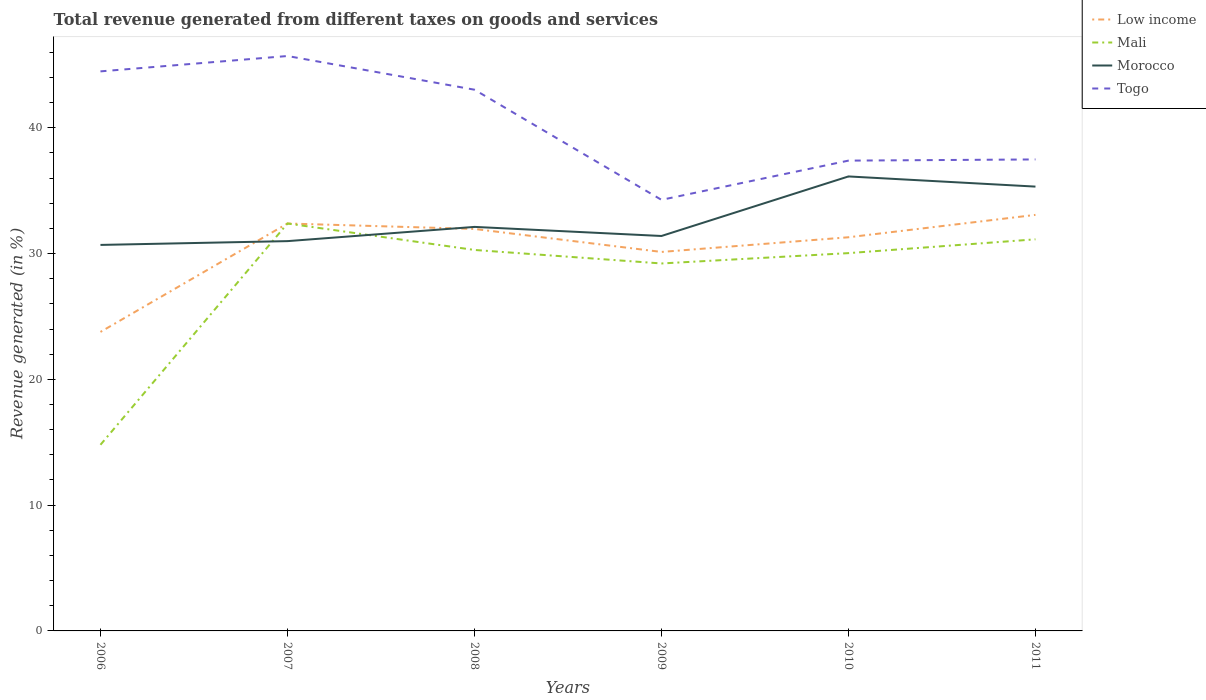Does the line corresponding to Mali intersect with the line corresponding to Morocco?
Keep it short and to the point. Yes. Across all years, what is the maximum total revenue generated in Low income?
Your answer should be compact. 23.77. In which year was the total revenue generated in Morocco maximum?
Keep it short and to the point. 2006. What is the total total revenue generated in Togo in the graph?
Your response must be concise. 10.21. What is the difference between the highest and the second highest total revenue generated in Low income?
Offer a very short reply. 9.31. Are the values on the major ticks of Y-axis written in scientific E-notation?
Your answer should be very brief. No. Does the graph contain grids?
Your answer should be compact. No. How are the legend labels stacked?
Provide a succinct answer. Vertical. What is the title of the graph?
Offer a very short reply. Total revenue generated from different taxes on goods and services. What is the label or title of the X-axis?
Offer a terse response. Years. What is the label or title of the Y-axis?
Your answer should be very brief. Revenue generated (in %). What is the Revenue generated (in %) of Low income in 2006?
Keep it short and to the point. 23.77. What is the Revenue generated (in %) in Mali in 2006?
Ensure brevity in your answer.  14.8. What is the Revenue generated (in %) in Morocco in 2006?
Keep it short and to the point. 30.69. What is the Revenue generated (in %) in Togo in 2006?
Offer a terse response. 44.49. What is the Revenue generated (in %) in Low income in 2007?
Give a very brief answer. 32.39. What is the Revenue generated (in %) of Mali in 2007?
Provide a short and direct response. 32.39. What is the Revenue generated (in %) in Morocco in 2007?
Your answer should be compact. 30.99. What is the Revenue generated (in %) in Togo in 2007?
Offer a terse response. 45.71. What is the Revenue generated (in %) in Low income in 2008?
Your answer should be very brief. 31.96. What is the Revenue generated (in %) of Mali in 2008?
Ensure brevity in your answer.  30.29. What is the Revenue generated (in %) of Morocco in 2008?
Give a very brief answer. 32.12. What is the Revenue generated (in %) in Togo in 2008?
Make the answer very short. 43.03. What is the Revenue generated (in %) of Low income in 2009?
Keep it short and to the point. 30.13. What is the Revenue generated (in %) in Mali in 2009?
Your answer should be compact. 29.21. What is the Revenue generated (in %) of Morocco in 2009?
Your answer should be very brief. 31.4. What is the Revenue generated (in %) of Togo in 2009?
Give a very brief answer. 34.27. What is the Revenue generated (in %) of Low income in 2010?
Give a very brief answer. 31.3. What is the Revenue generated (in %) in Mali in 2010?
Your response must be concise. 30.04. What is the Revenue generated (in %) of Morocco in 2010?
Your answer should be compact. 36.13. What is the Revenue generated (in %) of Togo in 2010?
Your response must be concise. 37.39. What is the Revenue generated (in %) in Low income in 2011?
Offer a terse response. 33.08. What is the Revenue generated (in %) of Mali in 2011?
Provide a short and direct response. 31.13. What is the Revenue generated (in %) in Morocco in 2011?
Your response must be concise. 35.33. What is the Revenue generated (in %) in Togo in 2011?
Your answer should be very brief. 37.48. Across all years, what is the maximum Revenue generated (in %) of Low income?
Give a very brief answer. 33.08. Across all years, what is the maximum Revenue generated (in %) of Mali?
Your answer should be compact. 32.39. Across all years, what is the maximum Revenue generated (in %) in Morocco?
Your answer should be very brief. 36.13. Across all years, what is the maximum Revenue generated (in %) of Togo?
Your response must be concise. 45.71. Across all years, what is the minimum Revenue generated (in %) of Low income?
Your answer should be compact. 23.77. Across all years, what is the minimum Revenue generated (in %) in Mali?
Provide a succinct answer. 14.8. Across all years, what is the minimum Revenue generated (in %) in Morocco?
Offer a terse response. 30.69. Across all years, what is the minimum Revenue generated (in %) of Togo?
Ensure brevity in your answer.  34.27. What is the total Revenue generated (in %) in Low income in the graph?
Ensure brevity in your answer.  182.63. What is the total Revenue generated (in %) in Mali in the graph?
Make the answer very short. 167.86. What is the total Revenue generated (in %) in Morocco in the graph?
Your response must be concise. 196.66. What is the total Revenue generated (in %) of Togo in the graph?
Your response must be concise. 242.37. What is the difference between the Revenue generated (in %) in Low income in 2006 and that in 2007?
Your response must be concise. -8.62. What is the difference between the Revenue generated (in %) in Mali in 2006 and that in 2007?
Ensure brevity in your answer.  -17.59. What is the difference between the Revenue generated (in %) of Morocco in 2006 and that in 2007?
Keep it short and to the point. -0.3. What is the difference between the Revenue generated (in %) in Togo in 2006 and that in 2007?
Give a very brief answer. -1.22. What is the difference between the Revenue generated (in %) of Low income in 2006 and that in 2008?
Your response must be concise. -8.19. What is the difference between the Revenue generated (in %) in Mali in 2006 and that in 2008?
Provide a short and direct response. -15.49. What is the difference between the Revenue generated (in %) of Morocco in 2006 and that in 2008?
Provide a short and direct response. -1.43. What is the difference between the Revenue generated (in %) in Togo in 2006 and that in 2008?
Provide a succinct answer. 1.46. What is the difference between the Revenue generated (in %) of Low income in 2006 and that in 2009?
Keep it short and to the point. -6.36. What is the difference between the Revenue generated (in %) in Mali in 2006 and that in 2009?
Your answer should be very brief. -14.42. What is the difference between the Revenue generated (in %) in Morocco in 2006 and that in 2009?
Your answer should be compact. -0.71. What is the difference between the Revenue generated (in %) of Togo in 2006 and that in 2009?
Your answer should be compact. 10.21. What is the difference between the Revenue generated (in %) in Low income in 2006 and that in 2010?
Your answer should be very brief. -7.53. What is the difference between the Revenue generated (in %) of Mali in 2006 and that in 2010?
Give a very brief answer. -15.24. What is the difference between the Revenue generated (in %) in Morocco in 2006 and that in 2010?
Make the answer very short. -5.44. What is the difference between the Revenue generated (in %) in Togo in 2006 and that in 2010?
Give a very brief answer. 7.1. What is the difference between the Revenue generated (in %) of Low income in 2006 and that in 2011?
Make the answer very short. -9.31. What is the difference between the Revenue generated (in %) of Mali in 2006 and that in 2011?
Your answer should be very brief. -16.34. What is the difference between the Revenue generated (in %) in Morocco in 2006 and that in 2011?
Your response must be concise. -4.64. What is the difference between the Revenue generated (in %) of Togo in 2006 and that in 2011?
Provide a short and direct response. 7. What is the difference between the Revenue generated (in %) in Low income in 2007 and that in 2008?
Keep it short and to the point. 0.43. What is the difference between the Revenue generated (in %) in Mali in 2007 and that in 2008?
Make the answer very short. 2.1. What is the difference between the Revenue generated (in %) of Morocco in 2007 and that in 2008?
Give a very brief answer. -1.13. What is the difference between the Revenue generated (in %) of Togo in 2007 and that in 2008?
Your answer should be compact. 2.68. What is the difference between the Revenue generated (in %) in Low income in 2007 and that in 2009?
Your answer should be compact. 2.26. What is the difference between the Revenue generated (in %) of Mali in 2007 and that in 2009?
Ensure brevity in your answer.  3.18. What is the difference between the Revenue generated (in %) in Morocco in 2007 and that in 2009?
Ensure brevity in your answer.  -0.41. What is the difference between the Revenue generated (in %) in Togo in 2007 and that in 2009?
Your answer should be very brief. 11.44. What is the difference between the Revenue generated (in %) of Low income in 2007 and that in 2010?
Your response must be concise. 1.09. What is the difference between the Revenue generated (in %) in Mali in 2007 and that in 2010?
Provide a succinct answer. 2.35. What is the difference between the Revenue generated (in %) in Morocco in 2007 and that in 2010?
Your answer should be very brief. -5.14. What is the difference between the Revenue generated (in %) in Togo in 2007 and that in 2010?
Offer a very short reply. 8.32. What is the difference between the Revenue generated (in %) in Low income in 2007 and that in 2011?
Offer a terse response. -0.69. What is the difference between the Revenue generated (in %) in Mali in 2007 and that in 2011?
Make the answer very short. 1.26. What is the difference between the Revenue generated (in %) in Morocco in 2007 and that in 2011?
Your answer should be compact. -4.34. What is the difference between the Revenue generated (in %) in Togo in 2007 and that in 2011?
Ensure brevity in your answer.  8.22. What is the difference between the Revenue generated (in %) in Low income in 2008 and that in 2009?
Offer a very short reply. 1.83. What is the difference between the Revenue generated (in %) of Mali in 2008 and that in 2009?
Give a very brief answer. 1.07. What is the difference between the Revenue generated (in %) of Morocco in 2008 and that in 2009?
Give a very brief answer. 0.72. What is the difference between the Revenue generated (in %) of Togo in 2008 and that in 2009?
Your response must be concise. 8.76. What is the difference between the Revenue generated (in %) in Low income in 2008 and that in 2010?
Ensure brevity in your answer.  0.66. What is the difference between the Revenue generated (in %) of Mali in 2008 and that in 2010?
Your answer should be compact. 0.25. What is the difference between the Revenue generated (in %) of Morocco in 2008 and that in 2010?
Offer a very short reply. -4.01. What is the difference between the Revenue generated (in %) in Togo in 2008 and that in 2010?
Provide a short and direct response. 5.64. What is the difference between the Revenue generated (in %) in Low income in 2008 and that in 2011?
Make the answer very short. -1.12. What is the difference between the Revenue generated (in %) in Mali in 2008 and that in 2011?
Keep it short and to the point. -0.85. What is the difference between the Revenue generated (in %) in Morocco in 2008 and that in 2011?
Your answer should be compact. -3.2. What is the difference between the Revenue generated (in %) in Togo in 2008 and that in 2011?
Keep it short and to the point. 5.54. What is the difference between the Revenue generated (in %) in Low income in 2009 and that in 2010?
Your answer should be very brief. -1.17. What is the difference between the Revenue generated (in %) in Mali in 2009 and that in 2010?
Ensure brevity in your answer.  -0.82. What is the difference between the Revenue generated (in %) in Morocco in 2009 and that in 2010?
Your response must be concise. -4.73. What is the difference between the Revenue generated (in %) in Togo in 2009 and that in 2010?
Offer a very short reply. -3.12. What is the difference between the Revenue generated (in %) of Low income in 2009 and that in 2011?
Ensure brevity in your answer.  -2.95. What is the difference between the Revenue generated (in %) of Mali in 2009 and that in 2011?
Ensure brevity in your answer.  -1.92. What is the difference between the Revenue generated (in %) in Morocco in 2009 and that in 2011?
Offer a terse response. -3.93. What is the difference between the Revenue generated (in %) of Togo in 2009 and that in 2011?
Provide a succinct answer. -3.21. What is the difference between the Revenue generated (in %) of Low income in 2010 and that in 2011?
Keep it short and to the point. -1.78. What is the difference between the Revenue generated (in %) in Mali in 2010 and that in 2011?
Make the answer very short. -1.1. What is the difference between the Revenue generated (in %) of Morocco in 2010 and that in 2011?
Keep it short and to the point. 0.81. What is the difference between the Revenue generated (in %) of Togo in 2010 and that in 2011?
Provide a succinct answer. -0.09. What is the difference between the Revenue generated (in %) of Low income in 2006 and the Revenue generated (in %) of Mali in 2007?
Give a very brief answer. -8.62. What is the difference between the Revenue generated (in %) in Low income in 2006 and the Revenue generated (in %) in Morocco in 2007?
Make the answer very short. -7.22. What is the difference between the Revenue generated (in %) of Low income in 2006 and the Revenue generated (in %) of Togo in 2007?
Keep it short and to the point. -21.94. What is the difference between the Revenue generated (in %) in Mali in 2006 and the Revenue generated (in %) in Morocco in 2007?
Offer a terse response. -16.19. What is the difference between the Revenue generated (in %) in Mali in 2006 and the Revenue generated (in %) in Togo in 2007?
Your answer should be compact. -30.91. What is the difference between the Revenue generated (in %) in Morocco in 2006 and the Revenue generated (in %) in Togo in 2007?
Ensure brevity in your answer.  -15.02. What is the difference between the Revenue generated (in %) in Low income in 2006 and the Revenue generated (in %) in Mali in 2008?
Provide a succinct answer. -6.52. What is the difference between the Revenue generated (in %) of Low income in 2006 and the Revenue generated (in %) of Morocco in 2008?
Your answer should be compact. -8.35. What is the difference between the Revenue generated (in %) of Low income in 2006 and the Revenue generated (in %) of Togo in 2008?
Your answer should be very brief. -19.26. What is the difference between the Revenue generated (in %) of Mali in 2006 and the Revenue generated (in %) of Morocco in 2008?
Ensure brevity in your answer.  -17.32. What is the difference between the Revenue generated (in %) in Mali in 2006 and the Revenue generated (in %) in Togo in 2008?
Make the answer very short. -28.23. What is the difference between the Revenue generated (in %) in Morocco in 2006 and the Revenue generated (in %) in Togo in 2008?
Your answer should be compact. -12.34. What is the difference between the Revenue generated (in %) in Low income in 2006 and the Revenue generated (in %) in Mali in 2009?
Make the answer very short. -5.44. What is the difference between the Revenue generated (in %) in Low income in 2006 and the Revenue generated (in %) in Morocco in 2009?
Provide a succinct answer. -7.63. What is the difference between the Revenue generated (in %) in Low income in 2006 and the Revenue generated (in %) in Togo in 2009?
Provide a succinct answer. -10.5. What is the difference between the Revenue generated (in %) of Mali in 2006 and the Revenue generated (in %) of Morocco in 2009?
Keep it short and to the point. -16.6. What is the difference between the Revenue generated (in %) of Mali in 2006 and the Revenue generated (in %) of Togo in 2009?
Provide a short and direct response. -19.47. What is the difference between the Revenue generated (in %) of Morocco in 2006 and the Revenue generated (in %) of Togo in 2009?
Provide a succinct answer. -3.58. What is the difference between the Revenue generated (in %) in Low income in 2006 and the Revenue generated (in %) in Mali in 2010?
Provide a short and direct response. -6.27. What is the difference between the Revenue generated (in %) of Low income in 2006 and the Revenue generated (in %) of Morocco in 2010?
Your answer should be very brief. -12.36. What is the difference between the Revenue generated (in %) of Low income in 2006 and the Revenue generated (in %) of Togo in 2010?
Ensure brevity in your answer.  -13.62. What is the difference between the Revenue generated (in %) in Mali in 2006 and the Revenue generated (in %) in Morocco in 2010?
Offer a terse response. -21.33. What is the difference between the Revenue generated (in %) of Mali in 2006 and the Revenue generated (in %) of Togo in 2010?
Give a very brief answer. -22.59. What is the difference between the Revenue generated (in %) of Morocco in 2006 and the Revenue generated (in %) of Togo in 2010?
Your answer should be very brief. -6.7. What is the difference between the Revenue generated (in %) in Low income in 2006 and the Revenue generated (in %) in Mali in 2011?
Your response must be concise. -7.36. What is the difference between the Revenue generated (in %) in Low income in 2006 and the Revenue generated (in %) in Morocco in 2011?
Your answer should be compact. -11.55. What is the difference between the Revenue generated (in %) in Low income in 2006 and the Revenue generated (in %) in Togo in 2011?
Give a very brief answer. -13.71. What is the difference between the Revenue generated (in %) in Mali in 2006 and the Revenue generated (in %) in Morocco in 2011?
Your answer should be very brief. -20.53. What is the difference between the Revenue generated (in %) of Mali in 2006 and the Revenue generated (in %) of Togo in 2011?
Ensure brevity in your answer.  -22.69. What is the difference between the Revenue generated (in %) in Morocco in 2006 and the Revenue generated (in %) in Togo in 2011?
Your response must be concise. -6.8. What is the difference between the Revenue generated (in %) of Low income in 2007 and the Revenue generated (in %) of Mali in 2008?
Ensure brevity in your answer.  2.1. What is the difference between the Revenue generated (in %) in Low income in 2007 and the Revenue generated (in %) in Morocco in 2008?
Provide a short and direct response. 0.27. What is the difference between the Revenue generated (in %) in Low income in 2007 and the Revenue generated (in %) in Togo in 2008?
Keep it short and to the point. -10.64. What is the difference between the Revenue generated (in %) of Mali in 2007 and the Revenue generated (in %) of Morocco in 2008?
Ensure brevity in your answer.  0.27. What is the difference between the Revenue generated (in %) of Mali in 2007 and the Revenue generated (in %) of Togo in 2008?
Your response must be concise. -10.64. What is the difference between the Revenue generated (in %) in Morocco in 2007 and the Revenue generated (in %) in Togo in 2008?
Keep it short and to the point. -12.04. What is the difference between the Revenue generated (in %) of Low income in 2007 and the Revenue generated (in %) of Mali in 2009?
Your answer should be compact. 3.18. What is the difference between the Revenue generated (in %) in Low income in 2007 and the Revenue generated (in %) in Togo in 2009?
Provide a succinct answer. -1.88. What is the difference between the Revenue generated (in %) of Mali in 2007 and the Revenue generated (in %) of Morocco in 2009?
Keep it short and to the point. 0.99. What is the difference between the Revenue generated (in %) in Mali in 2007 and the Revenue generated (in %) in Togo in 2009?
Offer a terse response. -1.88. What is the difference between the Revenue generated (in %) of Morocco in 2007 and the Revenue generated (in %) of Togo in 2009?
Offer a very short reply. -3.28. What is the difference between the Revenue generated (in %) of Low income in 2007 and the Revenue generated (in %) of Mali in 2010?
Provide a succinct answer. 2.35. What is the difference between the Revenue generated (in %) of Low income in 2007 and the Revenue generated (in %) of Morocco in 2010?
Provide a short and direct response. -3.74. What is the difference between the Revenue generated (in %) in Low income in 2007 and the Revenue generated (in %) in Togo in 2010?
Your answer should be compact. -5. What is the difference between the Revenue generated (in %) of Mali in 2007 and the Revenue generated (in %) of Morocco in 2010?
Your answer should be compact. -3.74. What is the difference between the Revenue generated (in %) of Mali in 2007 and the Revenue generated (in %) of Togo in 2010?
Your answer should be very brief. -5. What is the difference between the Revenue generated (in %) of Morocco in 2007 and the Revenue generated (in %) of Togo in 2010?
Provide a succinct answer. -6.4. What is the difference between the Revenue generated (in %) in Low income in 2007 and the Revenue generated (in %) in Mali in 2011?
Make the answer very short. 1.26. What is the difference between the Revenue generated (in %) of Low income in 2007 and the Revenue generated (in %) of Morocco in 2011?
Offer a very short reply. -2.93. What is the difference between the Revenue generated (in %) of Low income in 2007 and the Revenue generated (in %) of Togo in 2011?
Give a very brief answer. -5.09. What is the difference between the Revenue generated (in %) of Mali in 2007 and the Revenue generated (in %) of Morocco in 2011?
Ensure brevity in your answer.  -2.93. What is the difference between the Revenue generated (in %) in Mali in 2007 and the Revenue generated (in %) in Togo in 2011?
Your response must be concise. -5.09. What is the difference between the Revenue generated (in %) of Morocco in 2007 and the Revenue generated (in %) of Togo in 2011?
Offer a very short reply. -6.49. What is the difference between the Revenue generated (in %) in Low income in 2008 and the Revenue generated (in %) in Mali in 2009?
Your answer should be compact. 2.74. What is the difference between the Revenue generated (in %) of Low income in 2008 and the Revenue generated (in %) of Morocco in 2009?
Provide a short and direct response. 0.56. What is the difference between the Revenue generated (in %) in Low income in 2008 and the Revenue generated (in %) in Togo in 2009?
Give a very brief answer. -2.31. What is the difference between the Revenue generated (in %) of Mali in 2008 and the Revenue generated (in %) of Morocco in 2009?
Keep it short and to the point. -1.11. What is the difference between the Revenue generated (in %) of Mali in 2008 and the Revenue generated (in %) of Togo in 2009?
Give a very brief answer. -3.98. What is the difference between the Revenue generated (in %) of Morocco in 2008 and the Revenue generated (in %) of Togo in 2009?
Provide a short and direct response. -2.15. What is the difference between the Revenue generated (in %) of Low income in 2008 and the Revenue generated (in %) of Mali in 2010?
Provide a succinct answer. 1.92. What is the difference between the Revenue generated (in %) in Low income in 2008 and the Revenue generated (in %) in Morocco in 2010?
Provide a short and direct response. -4.17. What is the difference between the Revenue generated (in %) of Low income in 2008 and the Revenue generated (in %) of Togo in 2010?
Provide a short and direct response. -5.43. What is the difference between the Revenue generated (in %) in Mali in 2008 and the Revenue generated (in %) in Morocco in 2010?
Keep it short and to the point. -5.84. What is the difference between the Revenue generated (in %) in Mali in 2008 and the Revenue generated (in %) in Togo in 2010?
Your answer should be very brief. -7.1. What is the difference between the Revenue generated (in %) of Morocco in 2008 and the Revenue generated (in %) of Togo in 2010?
Provide a short and direct response. -5.27. What is the difference between the Revenue generated (in %) of Low income in 2008 and the Revenue generated (in %) of Mali in 2011?
Your answer should be compact. 0.82. What is the difference between the Revenue generated (in %) in Low income in 2008 and the Revenue generated (in %) in Morocco in 2011?
Keep it short and to the point. -3.37. What is the difference between the Revenue generated (in %) in Low income in 2008 and the Revenue generated (in %) in Togo in 2011?
Offer a very short reply. -5.53. What is the difference between the Revenue generated (in %) of Mali in 2008 and the Revenue generated (in %) of Morocco in 2011?
Offer a very short reply. -5.04. What is the difference between the Revenue generated (in %) of Mali in 2008 and the Revenue generated (in %) of Togo in 2011?
Provide a short and direct response. -7.2. What is the difference between the Revenue generated (in %) in Morocco in 2008 and the Revenue generated (in %) in Togo in 2011?
Keep it short and to the point. -5.36. What is the difference between the Revenue generated (in %) of Low income in 2009 and the Revenue generated (in %) of Mali in 2010?
Offer a very short reply. 0.09. What is the difference between the Revenue generated (in %) of Low income in 2009 and the Revenue generated (in %) of Morocco in 2010?
Make the answer very short. -6. What is the difference between the Revenue generated (in %) of Low income in 2009 and the Revenue generated (in %) of Togo in 2010?
Ensure brevity in your answer.  -7.26. What is the difference between the Revenue generated (in %) of Mali in 2009 and the Revenue generated (in %) of Morocco in 2010?
Provide a succinct answer. -6.92. What is the difference between the Revenue generated (in %) of Mali in 2009 and the Revenue generated (in %) of Togo in 2010?
Offer a very short reply. -8.18. What is the difference between the Revenue generated (in %) of Morocco in 2009 and the Revenue generated (in %) of Togo in 2010?
Your answer should be compact. -5.99. What is the difference between the Revenue generated (in %) in Low income in 2009 and the Revenue generated (in %) in Mali in 2011?
Your response must be concise. -1. What is the difference between the Revenue generated (in %) of Low income in 2009 and the Revenue generated (in %) of Morocco in 2011?
Your answer should be compact. -5.19. What is the difference between the Revenue generated (in %) of Low income in 2009 and the Revenue generated (in %) of Togo in 2011?
Provide a succinct answer. -7.35. What is the difference between the Revenue generated (in %) in Mali in 2009 and the Revenue generated (in %) in Morocco in 2011?
Offer a terse response. -6.11. What is the difference between the Revenue generated (in %) in Mali in 2009 and the Revenue generated (in %) in Togo in 2011?
Keep it short and to the point. -8.27. What is the difference between the Revenue generated (in %) in Morocco in 2009 and the Revenue generated (in %) in Togo in 2011?
Your response must be concise. -6.09. What is the difference between the Revenue generated (in %) of Low income in 2010 and the Revenue generated (in %) of Mali in 2011?
Ensure brevity in your answer.  0.16. What is the difference between the Revenue generated (in %) of Low income in 2010 and the Revenue generated (in %) of Morocco in 2011?
Your response must be concise. -4.03. What is the difference between the Revenue generated (in %) in Low income in 2010 and the Revenue generated (in %) in Togo in 2011?
Make the answer very short. -6.19. What is the difference between the Revenue generated (in %) of Mali in 2010 and the Revenue generated (in %) of Morocco in 2011?
Offer a terse response. -5.29. What is the difference between the Revenue generated (in %) of Mali in 2010 and the Revenue generated (in %) of Togo in 2011?
Your response must be concise. -7.45. What is the difference between the Revenue generated (in %) in Morocco in 2010 and the Revenue generated (in %) in Togo in 2011?
Give a very brief answer. -1.35. What is the average Revenue generated (in %) in Low income per year?
Keep it short and to the point. 30.44. What is the average Revenue generated (in %) in Mali per year?
Offer a terse response. 27.98. What is the average Revenue generated (in %) of Morocco per year?
Ensure brevity in your answer.  32.78. What is the average Revenue generated (in %) in Togo per year?
Offer a very short reply. 40.4. In the year 2006, what is the difference between the Revenue generated (in %) of Low income and Revenue generated (in %) of Mali?
Keep it short and to the point. 8.97. In the year 2006, what is the difference between the Revenue generated (in %) of Low income and Revenue generated (in %) of Morocco?
Provide a short and direct response. -6.92. In the year 2006, what is the difference between the Revenue generated (in %) in Low income and Revenue generated (in %) in Togo?
Provide a short and direct response. -20.71. In the year 2006, what is the difference between the Revenue generated (in %) in Mali and Revenue generated (in %) in Morocco?
Give a very brief answer. -15.89. In the year 2006, what is the difference between the Revenue generated (in %) of Mali and Revenue generated (in %) of Togo?
Your answer should be very brief. -29.69. In the year 2006, what is the difference between the Revenue generated (in %) in Morocco and Revenue generated (in %) in Togo?
Provide a succinct answer. -13.8. In the year 2007, what is the difference between the Revenue generated (in %) in Low income and Revenue generated (in %) in Mali?
Offer a terse response. 0. In the year 2007, what is the difference between the Revenue generated (in %) in Low income and Revenue generated (in %) in Morocco?
Ensure brevity in your answer.  1.4. In the year 2007, what is the difference between the Revenue generated (in %) in Low income and Revenue generated (in %) in Togo?
Ensure brevity in your answer.  -13.32. In the year 2007, what is the difference between the Revenue generated (in %) of Mali and Revenue generated (in %) of Morocco?
Your answer should be very brief. 1.4. In the year 2007, what is the difference between the Revenue generated (in %) of Mali and Revenue generated (in %) of Togo?
Your answer should be compact. -13.32. In the year 2007, what is the difference between the Revenue generated (in %) in Morocco and Revenue generated (in %) in Togo?
Provide a short and direct response. -14.72. In the year 2008, what is the difference between the Revenue generated (in %) of Low income and Revenue generated (in %) of Mali?
Provide a short and direct response. 1.67. In the year 2008, what is the difference between the Revenue generated (in %) of Low income and Revenue generated (in %) of Morocco?
Give a very brief answer. -0.16. In the year 2008, what is the difference between the Revenue generated (in %) in Low income and Revenue generated (in %) in Togo?
Provide a succinct answer. -11.07. In the year 2008, what is the difference between the Revenue generated (in %) in Mali and Revenue generated (in %) in Morocco?
Provide a succinct answer. -1.83. In the year 2008, what is the difference between the Revenue generated (in %) in Mali and Revenue generated (in %) in Togo?
Your answer should be very brief. -12.74. In the year 2008, what is the difference between the Revenue generated (in %) in Morocco and Revenue generated (in %) in Togo?
Provide a succinct answer. -10.91. In the year 2009, what is the difference between the Revenue generated (in %) of Low income and Revenue generated (in %) of Mali?
Your answer should be very brief. 0.92. In the year 2009, what is the difference between the Revenue generated (in %) of Low income and Revenue generated (in %) of Morocco?
Provide a succinct answer. -1.27. In the year 2009, what is the difference between the Revenue generated (in %) in Low income and Revenue generated (in %) in Togo?
Make the answer very short. -4.14. In the year 2009, what is the difference between the Revenue generated (in %) of Mali and Revenue generated (in %) of Morocco?
Your answer should be very brief. -2.19. In the year 2009, what is the difference between the Revenue generated (in %) of Mali and Revenue generated (in %) of Togo?
Offer a very short reply. -5.06. In the year 2009, what is the difference between the Revenue generated (in %) of Morocco and Revenue generated (in %) of Togo?
Provide a succinct answer. -2.87. In the year 2010, what is the difference between the Revenue generated (in %) in Low income and Revenue generated (in %) in Mali?
Keep it short and to the point. 1.26. In the year 2010, what is the difference between the Revenue generated (in %) in Low income and Revenue generated (in %) in Morocco?
Offer a very short reply. -4.84. In the year 2010, what is the difference between the Revenue generated (in %) in Low income and Revenue generated (in %) in Togo?
Offer a very short reply. -6.09. In the year 2010, what is the difference between the Revenue generated (in %) of Mali and Revenue generated (in %) of Morocco?
Keep it short and to the point. -6.1. In the year 2010, what is the difference between the Revenue generated (in %) in Mali and Revenue generated (in %) in Togo?
Ensure brevity in your answer.  -7.35. In the year 2010, what is the difference between the Revenue generated (in %) in Morocco and Revenue generated (in %) in Togo?
Ensure brevity in your answer.  -1.26. In the year 2011, what is the difference between the Revenue generated (in %) of Low income and Revenue generated (in %) of Mali?
Your response must be concise. 1.94. In the year 2011, what is the difference between the Revenue generated (in %) in Low income and Revenue generated (in %) in Morocco?
Your answer should be very brief. -2.25. In the year 2011, what is the difference between the Revenue generated (in %) of Low income and Revenue generated (in %) of Togo?
Provide a succinct answer. -4.41. In the year 2011, what is the difference between the Revenue generated (in %) of Mali and Revenue generated (in %) of Morocco?
Your answer should be compact. -4.19. In the year 2011, what is the difference between the Revenue generated (in %) in Mali and Revenue generated (in %) in Togo?
Provide a succinct answer. -6.35. In the year 2011, what is the difference between the Revenue generated (in %) in Morocco and Revenue generated (in %) in Togo?
Make the answer very short. -2.16. What is the ratio of the Revenue generated (in %) in Low income in 2006 to that in 2007?
Give a very brief answer. 0.73. What is the ratio of the Revenue generated (in %) in Mali in 2006 to that in 2007?
Provide a short and direct response. 0.46. What is the ratio of the Revenue generated (in %) in Morocco in 2006 to that in 2007?
Ensure brevity in your answer.  0.99. What is the ratio of the Revenue generated (in %) of Togo in 2006 to that in 2007?
Keep it short and to the point. 0.97. What is the ratio of the Revenue generated (in %) in Low income in 2006 to that in 2008?
Provide a short and direct response. 0.74. What is the ratio of the Revenue generated (in %) of Mali in 2006 to that in 2008?
Your response must be concise. 0.49. What is the ratio of the Revenue generated (in %) in Morocco in 2006 to that in 2008?
Offer a terse response. 0.96. What is the ratio of the Revenue generated (in %) of Togo in 2006 to that in 2008?
Give a very brief answer. 1.03. What is the ratio of the Revenue generated (in %) of Low income in 2006 to that in 2009?
Offer a very short reply. 0.79. What is the ratio of the Revenue generated (in %) of Mali in 2006 to that in 2009?
Give a very brief answer. 0.51. What is the ratio of the Revenue generated (in %) of Morocco in 2006 to that in 2009?
Keep it short and to the point. 0.98. What is the ratio of the Revenue generated (in %) in Togo in 2006 to that in 2009?
Offer a very short reply. 1.3. What is the ratio of the Revenue generated (in %) in Low income in 2006 to that in 2010?
Ensure brevity in your answer.  0.76. What is the ratio of the Revenue generated (in %) of Mali in 2006 to that in 2010?
Your answer should be compact. 0.49. What is the ratio of the Revenue generated (in %) of Morocco in 2006 to that in 2010?
Offer a very short reply. 0.85. What is the ratio of the Revenue generated (in %) in Togo in 2006 to that in 2010?
Your response must be concise. 1.19. What is the ratio of the Revenue generated (in %) of Low income in 2006 to that in 2011?
Keep it short and to the point. 0.72. What is the ratio of the Revenue generated (in %) of Mali in 2006 to that in 2011?
Your answer should be very brief. 0.48. What is the ratio of the Revenue generated (in %) in Morocco in 2006 to that in 2011?
Your answer should be compact. 0.87. What is the ratio of the Revenue generated (in %) in Togo in 2006 to that in 2011?
Ensure brevity in your answer.  1.19. What is the ratio of the Revenue generated (in %) of Low income in 2007 to that in 2008?
Your answer should be compact. 1.01. What is the ratio of the Revenue generated (in %) in Mali in 2007 to that in 2008?
Keep it short and to the point. 1.07. What is the ratio of the Revenue generated (in %) of Morocco in 2007 to that in 2008?
Make the answer very short. 0.96. What is the ratio of the Revenue generated (in %) in Togo in 2007 to that in 2008?
Give a very brief answer. 1.06. What is the ratio of the Revenue generated (in %) of Low income in 2007 to that in 2009?
Provide a short and direct response. 1.07. What is the ratio of the Revenue generated (in %) of Mali in 2007 to that in 2009?
Offer a very short reply. 1.11. What is the ratio of the Revenue generated (in %) in Togo in 2007 to that in 2009?
Keep it short and to the point. 1.33. What is the ratio of the Revenue generated (in %) of Low income in 2007 to that in 2010?
Make the answer very short. 1.03. What is the ratio of the Revenue generated (in %) of Mali in 2007 to that in 2010?
Keep it short and to the point. 1.08. What is the ratio of the Revenue generated (in %) of Morocco in 2007 to that in 2010?
Provide a succinct answer. 0.86. What is the ratio of the Revenue generated (in %) in Togo in 2007 to that in 2010?
Offer a very short reply. 1.22. What is the ratio of the Revenue generated (in %) in Low income in 2007 to that in 2011?
Provide a short and direct response. 0.98. What is the ratio of the Revenue generated (in %) of Mali in 2007 to that in 2011?
Provide a succinct answer. 1.04. What is the ratio of the Revenue generated (in %) in Morocco in 2007 to that in 2011?
Provide a succinct answer. 0.88. What is the ratio of the Revenue generated (in %) in Togo in 2007 to that in 2011?
Your answer should be very brief. 1.22. What is the ratio of the Revenue generated (in %) in Low income in 2008 to that in 2009?
Offer a terse response. 1.06. What is the ratio of the Revenue generated (in %) in Mali in 2008 to that in 2009?
Your answer should be compact. 1.04. What is the ratio of the Revenue generated (in %) in Togo in 2008 to that in 2009?
Your response must be concise. 1.26. What is the ratio of the Revenue generated (in %) in Low income in 2008 to that in 2010?
Offer a very short reply. 1.02. What is the ratio of the Revenue generated (in %) in Mali in 2008 to that in 2010?
Your answer should be compact. 1.01. What is the ratio of the Revenue generated (in %) in Morocco in 2008 to that in 2010?
Make the answer very short. 0.89. What is the ratio of the Revenue generated (in %) of Togo in 2008 to that in 2010?
Provide a succinct answer. 1.15. What is the ratio of the Revenue generated (in %) of Low income in 2008 to that in 2011?
Your answer should be compact. 0.97. What is the ratio of the Revenue generated (in %) in Mali in 2008 to that in 2011?
Offer a very short reply. 0.97. What is the ratio of the Revenue generated (in %) in Morocco in 2008 to that in 2011?
Offer a very short reply. 0.91. What is the ratio of the Revenue generated (in %) of Togo in 2008 to that in 2011?
Your answer should be compact. 1.15. What is the ratio of the Revenue generated (in %) in Low income in 2009 to that in 2010?
Your response must be concise. 0.96. What is the ratio of the Revenue generated (in %) in Mali in 2009 to that in 2010?
Ensure brevity in your answer.  0.97. What is the ratio of the Revenue generated (in %) in Morocco in 2009 to that in 2010?
Your answer should be very brief. 0.87. What is the ratio of the Revenue generated (in %) in Togo in 2009 to that in 2010?
Offer a very short reply. 0.92. What is the ratio of the Revenue generated (in %) of Low income in 2009 to that in 2011?
Offer a terse response. 0.91. What is the ratio of the Revenue generated (in %) in Mali in 2009 to that in 2011?
Ensure brevity in your answer.  0.94. What is the ratio of the Revenue generated (in %) in Togo in 2009 to that in 2011?
Provide a succinct answer. 0.91. What is the ratio of the Revenue generated (in %) of Low income in 2010 to that in 2011?
Provide a succinct answer. 0.95. What is the ratio of the Revenue generated (in %) of Mali in 2010 to that in 2011?
Ensure brevity in your answer.  0.96. What is the ratio of the Revenue generated (in %) in Morocco in 2010 to that in 2011?
Provide a short and direct response. 1.02. What is the difference between the highest and the second highest Revenue generated (in %) in Low income?
Make the answer very short. 0.69. What is the difference between the highest and the second highest Revenue generated (in %) of Mali?
Offer a very short reply. 1.26. What is the difference between the highest and the second highest Revenue generated (in %) in Morocco?
Keep it short and to the point. 0.81. What is the difference between the highest and the second highest Revenue generated (in %) in Togo?
Ensure brevity in your answer.  1.22. What is the difference between the highest and the lowest Revenue generated (in %) in Low income?
Your response must be concise. 9.31. What is the difference between the highest and the lowest Revenue generated (in %) of Mali?
Provide a short and direct response. 17.59. What is the difference between the highest and the lowest Revenue generated (in %) of Morocco?
Your answer should be compact. 5.44. What is the difference between the highest and the lowest Revenue generated (in %) in Togo?
Give a very brief answer. 11.44. 